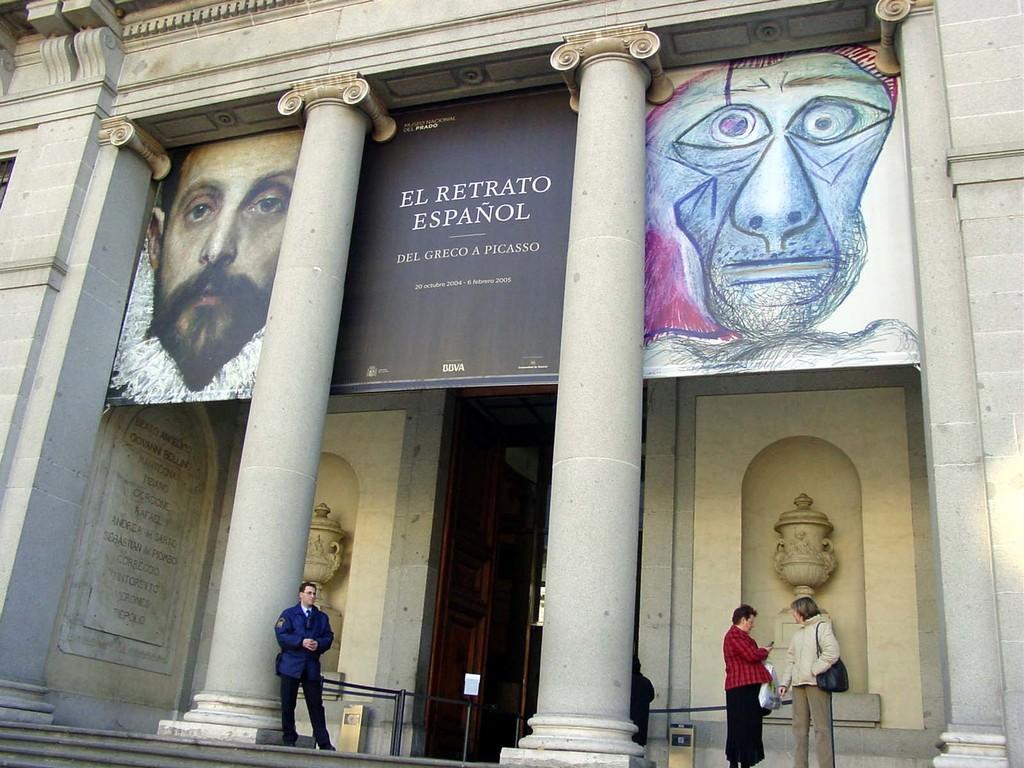In one or two sentences, can you explain what this image depicts? In this picture, we can see a few people, building, pillar, stairs, wall with door, and some text on the wall, and we can see poster with images, and some text on it. 